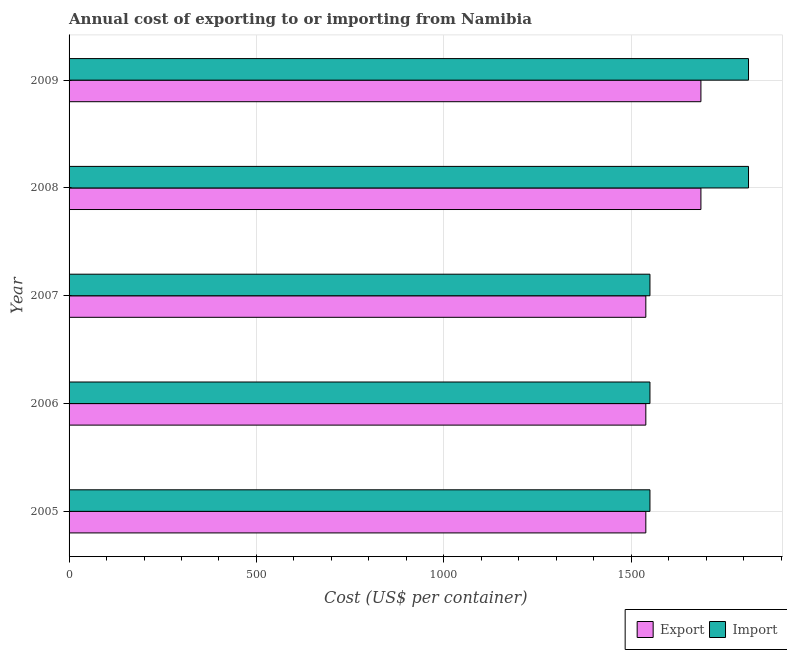Are the number of bars per tick equal to the number of legend labels?
Provide a short and direct response. Yes. How many bars are there on the 5th tick from the bottom?
Make the answer very short. 2. What is the label of the 5th group of bars from the top?
Your response must be concise. 2005. In how many cases, is the number of bars for a given year not equal to the number of legend labels?
Keep it short and to the point. 0. What is the export cost in 2008?
Offer a terse response. 1686. Across all years, what is the maximum export cost?
Ensure brevity in your answer.  1686. Across all years, what is the minimum import cost?
Offer a terse response. 1550. What is the total export cost in the graph?
Ensure brevity in your answer.  7989. What is the difference between the import cost in 2007 and that in 2008?
Offer a terse response. -263. What is the difference between the import cost in 2005 and the export cost in 2007?
Your response must be concise. 11. What is the average import cost per year?
Provide a succinct answer. 1655.2. In the year 2006, what is the difference between the import cost and export cost?
Make the answer very short. 11. What is the difference between the highest and the lowest import cost?
Your answer should be very brief. 263. In how many years, is the import cost greater than the average import cost taken over all years?
Your response must be concise. 2. What does the 1st bar from the top in 2005 represents?
Offer a terse response. Import. What does the 2nd bar from the bottom in 2009 represents?
Offer a terse response. Import. How many bars are there?
Provide a succinct answer. 10. Does the graph contain grids?
Your answer should be compact. Yes. Where does the legend appear in the graph?
Ensure brevity in your answer.  Bottom right. What is the title of the graph?
Your response must be concise. Annual cost of exporting to or importing from Namibia. What is the label or title of the X-axis?
Keep it short and to the point. Cost (US$ per container). What is the Cost (US$ per container) in Export in 2005?
Give a very brief answer. 1539. What is the Cost (US$ per container) of Import in 2005?
Ensure brevity in your answer.  1550. What is the Cost (US$ per container) in Export in 2006?
Offer a very short reply. 1539. What is the Cost (US$ per container) in Import in 2006?
Give a very brief answer. 1550. What is the Cost (US$ per container) in Export in 2007?
Provide a succinct answer. 1539. What is the Cost (US$ per container) of Import in 2007?
Your response must be concise. 1550. What is the Cost (US$ per container) in Export in 2008?
Offer a terse response. 1686. What is the Cost (US$ per container) of Import in 2008?
Provide a short and direct response. 1813. What is the Cost (US$ per container) in Export in 2009?
Provide a short and direct response. 1686. What is the Cost (US$ per container) in Import in 2009?
Your response must be concise. 1813. Across all years, what is the maximum Cost (US$ per container) of Export?
Make the answer very short. 1686. Across all years, what is the maximum Cost (US$ per container) of Import?
Offer a very short reply. 1813. Across all years, what is the minimum Cost (US$ per container) in Export?
Your answer should be compact. 1539. Across all years, what is the minimum Cost (US$ per container) of Import?
Your answer should be compact. 1550. What is the total Cost (US$ per container) in Export in the graph?
Provide a succinct answer. 7989. What is the total Cost (US$ per container) in Import in the graph?
Provide a succinct answer. 8276. What is the difference between the Cost (US$ per container) in Export in 2005 and that in 2006?
Ensure brevity in your answer.  0. What is the difference between the Cost (US$ per container) in Export in 2005 and that in 2008?
Give a very brief answer. -147. What is the difference between the Cost (US$ per container) in Import in 2005 and that in 2008?
Offer a very short reply. -263. What is the difference between the Cost (US$ per container) in Export in 2005 and that in 2009?
Give a very brief answer. -147. What is the difference between the Cost (US$ per container) in Import in 2005 and that in 2009?
Provide a short and direct response. -263. What is the difference between the Cost (US$ per container) of Export in 2006 and that in 2008?
Keep it short and to the point. -147. What is the difference between the Cost (US$ per container) of Import in 2006 and that in 2008?
Your answer should be very brief. -263. What is the difference between the Cost (US$ per container) in Export in 2006 and that in 2009?
Offer a very short reply. -147. What is the difference between the Cost (US$ per container) in Import in 2006 and that in 2009?
Your response must be concise. -263. What is the difference between the Cost (US$ per container) in Export in 2007 and that in 2008?
Provide a succinct answer. -147. What is the difference between the Cost (US$ per container) in Import in 2007 and that in 2008?
Provide a short and direct response. -263. What is the difference between the Cost (US$ per container) in Export in 2007 and that in 2009?
Offer a terse response. -147. What is the difference between the Cost (US$ per container) of Import in 2007 and that in 2009?
Ensure brevity in your answer.  -263. What is the difference between the Cost (US$ per container) of Export in 2008 and that in 2009?
Your response must be concise. 0. What is the difference between the Cost (US$ per container) in Export in 2005 and the Cost (US$ per container) in Import in 2006?
Provide a succinct answer. -11. What is the difference between the Cost (US$ per container) in Export in 2005 and the Cost (US$ per container) in Import in 2008?
Provide a short and direct response. -274. What is the difference between the Cost (US$ per container) of Export in 2005 and the Cost (US$ per container) of Import in 2009?
Offer a very short reply. -274. What is the difference between the Cost (US$ per container) of Export in 2006 and the Cost (US$ per container) of Import in 2008?
Keep it short and to the point. -274. What is the difference between the Cost (US$ per container) of Export in 2006 and the Cost (US$ per container) of Import in 2009?
Provide a succinct answer. -274. What is the difference between the Cost (US$ per container) of Export in 2007 and the Cost (US$ per container) of Import in 2008?
Make the answer very short. -274. What is the difference between the Cost (US$ per container) of Export in 2007 and the Cost (US$ per container) of Import in 2009?
Give a very brief answer. -274. What is the difference between the Cost (US$ per container) in Export in 2008 and the Cost (US$ per container) in Import in 2009?
Make the answer very short. -127. What is the average Cost (US$ per container) in Export per year?
Give a very brief answer. 1597.8. What is the average Cost (US$ per container) in Import per year?
Give a very brief answer. 1655.2. In the year 2005, what is the difference between the Cost (US$ per container) in Export and Cost (US$ per container) in Import?
Make the answer very short. -11. In the year 2007, what is the difference between the Cost (US$ per container) of Export and Cost (US$ per container) of Import?
Provide a short and direct response. -11. In the year 2008, what is the difference between the Cost (US$ per container) of Export and Cost (US$ per container) of Import?
Ensure brevity in your answer.  -127. In the year 2009, what is the difference between the Cost (US$ per container) of Export and Cost (US$ per container) of Import?
Your response must be concise. -127. What is the ratio of the Cost (US$ per container) of Export in 2005 to that in 2006?
Provide a succinct answer. 1. What is the ratio of the Cost (US$ per container) in Export in 2005 to that in 2008?
Make the answer very short. 0.91. What is the ratio of the Cost (US$ per container) of Import in 2005 to that in 2008?
Your response must be concise. 0.85. What is the ratio of the Cost (US$ per container) of Export in 2005 to that in 2009?
Offer a very short reply. 0.91. What is the ratio of the Cost (US$ per container) in Import in 2005 to that in 2009?
Offer a terse response. 0.85. What is the ratio of the Cost (US$ per container) in Export in 2006 to that in 2007?
Offer a terse response. 1. What is the ratio of the Cost (US$ per container) in Export in 2006 to that in 2008?
Provide a succinct answer. 0.91. What is the ratio of the Cost (US$ per container) of Import in 2006 to that in 2008?
Make the answer very short. 0.85. What is the ratio of the Cost (US$ per container) of Export in 2006 to that in 2009?
Keep it short and to the point. 0.91. What is the ratio of the Cost (US$ per container) of Import in 2006 to that in 2009?
Provide a short and direct response. 0.85. What is the ratio of the Cost (US$ per container) of Export in 2007 to that in 2008?
Ensure brevity in your answer.  0.91. What is the ratio of the Cost (US$ per container) in Import in 2007 to that in 2008?
Give a very brief answer. 0.85. What is the ratio of the Cost (US$ per container) in Export in 2007 to that in 2009?
Your response must be concise. 0.91. What is the ratio of the Cost (US$ per container) in Import in 2007 to that in 2009?
Give a very brief answer. 0.85. What is the ratio of the Cost (US$ per container) in Import in 2008 to that in 2009?
Provide a short and direct response. 1. What is the difference between the highest and the second highest Cost (US$ per container) in Export?
Offer a very short reply. 0. What is the difference between the highest and the second highest Cost (US$ per container) of Import?
Ensure brevity in your answer.  0. What is the difference between the highest and the lowest Cost (US$ per container) of Export?
Offer a very short reply. 147. What is the difference between the highest and the lowest Cost (US$ per container) of Import?
Provide a short and direct response. 263. 